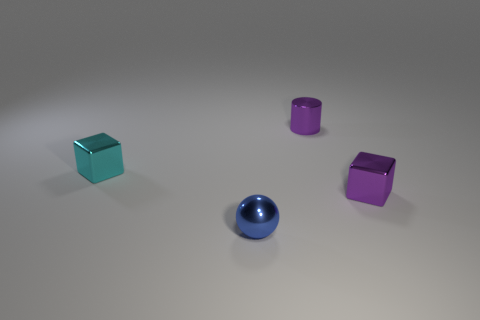Which objects in the image are closest to each other? Observing the positions of the objects in the image, the magenta cube and the blue sphere appear to be the closest to each other. What do you think could be the relationship between these objects? While the objects are inanimate, if we were to create a narrative, we might imagine they are set pieces in a game or parts of a decorative assembly, where their proximity might suggest an intentional arrangement for aesthetic balance or functional purpose within a larger context. 